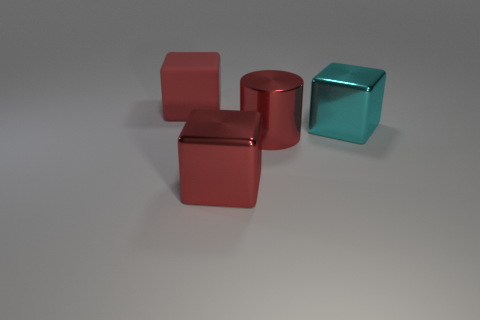Is the number of metal objects on the left side of the matte thing less than the number of red things on the right side of the red shiny cube? Yes, that's correct. Upon careful observation of the image, there appears to be one matte object on the left side, which is greatly outnumbered by the three red items on the right side, ensuring that the number of metal objects on the left is indeed less than the number of red objects on the right. 